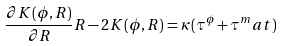<formula> <loc_0><loc_0><loc_500><loc_500>\frac { \partial K ( \phi , R ) } { \partial R } R - 2 K ( \phi , R ) = \kappa ( \tau ^ { \phi } + \tau ^ { m } a t )</formula> 